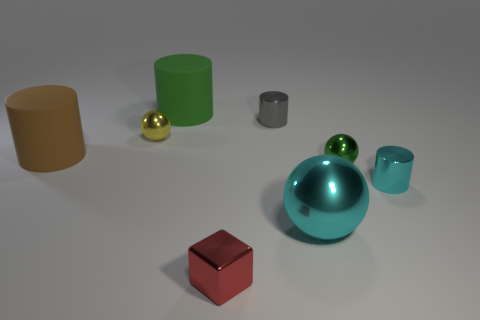Do the big cylinder in front of the small yellow object and the tiny cyan object have the same material?
Ensure brevity in your answer.  No. Are there fewer tiny blocks that are on the left side of the cube than metal blocks?
Give a very brief answer. Yes. What number of metal things are cyan cylinders or big brown cylinders?
Provide a succinct answer. 1. Is the color of the big shiny ball the same as the small cube?
Provide a succinct answer. No. Is there anything else that is the same color as the small cube?
Make the answer very short. No. Do the large object on the right side of the red metallic thing and the small metal thing to the left of the tiny red metallic cube have the same shape?
Provide a succinct answer. Yes. How many objects are either big cyan rubber things or big rubber cylinders that are behind the big brown cylinder?
Your answer should be compact. 1. How many other objects are the same size as the green ball?
Provide a succinct answer. 4. Are the small cylinder in front of the tiny green metallic ball and the small cylinder on the left side of the green metallic object made of the same material?
Provide a succinct answer. Yes. How many cyan objects are behind the small gray metal cylinder?
Keep it short and to the point. 0. 